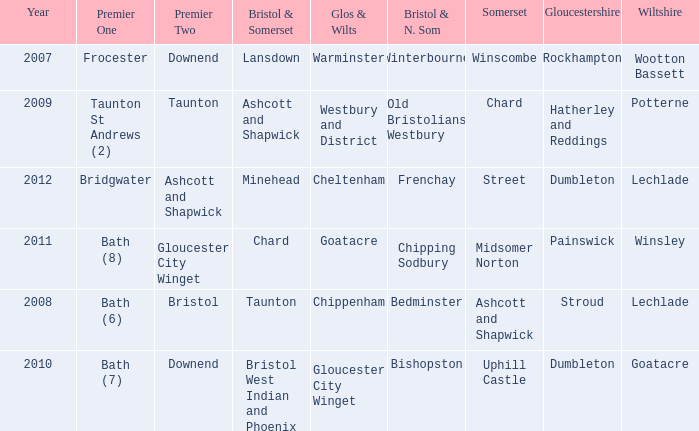What is the glos & wilts where the bristol & somerset is lansdown? Warminster. 